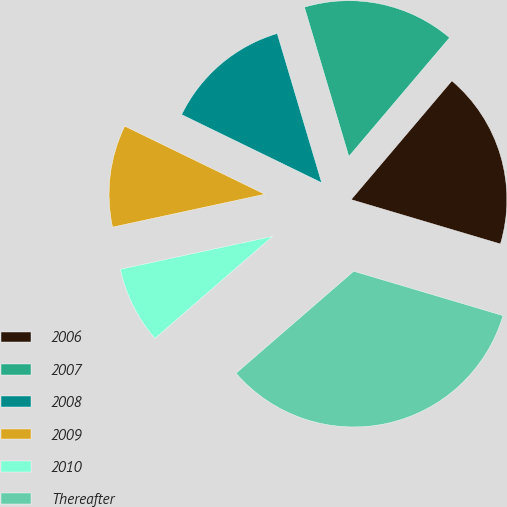Convert chart to OTSL. <chart><loc_0><loc_0><loc_500><loc_500><pie_chart><fcel>2006<fcel>2007<fcel>2008<fcel>2009<fcel>2010<fcel>Thereafter<nl><fcel>18.4%<fcel>15.8%<fcel>13.19%<fcel>10.59%<fcel>7.98%<fcel>34.03%<nl></chart> 